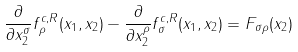<formula> <loc_0><loc_0><loc_500><loc_500>\frac { \partial } { \partial x _ { 2 } ^ { \sigma } } f _ { \rho } ^ { c , R } ( x _ { 1 } , x _ { 2 } ) - \frac { \partial } { \partial x _ { 2 } ^ { \rho } } f _ { \sigma } ^ { c , R } ( x _ { 1 } , x _ { 2 } ) = F _ { \sigma \rho } ( x _ { 2 } )</formula> 